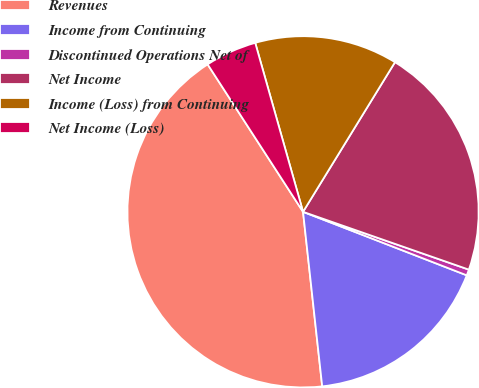Convert chart. <chart><loc_0><loc_0><loc_500><loc_500><pie_chart><fcel>Revenues<fcel>Income from Continuing<fcel>Discontinued Operations Net of<fcel>Net Income<fcel>Income (Loss) from Continuing<fcel>Net Income (Loss)<nl><fcel>42.6%<fcel>17.37%<fcel>0.55%<fcel>21.57%<fcel>13.16%<fcel>4.75%<nl></chart> 